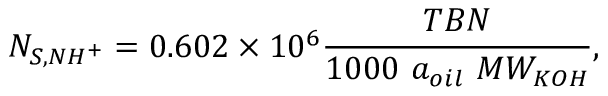<formula> <loc_0><loc_0><loc_500><loc_500>N _ { S , N H ^ { + } } = 0 . 6 0 2 \times 1 0 ^ { 6 } \frac { T B N } { 1 0 0 0 a _ { o i l } M W _ { K O H } } ,</formula> 